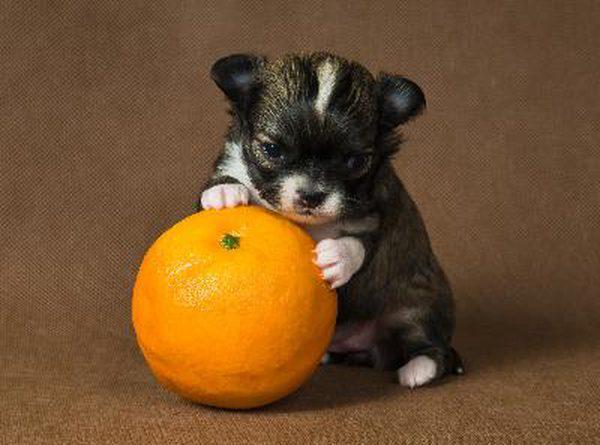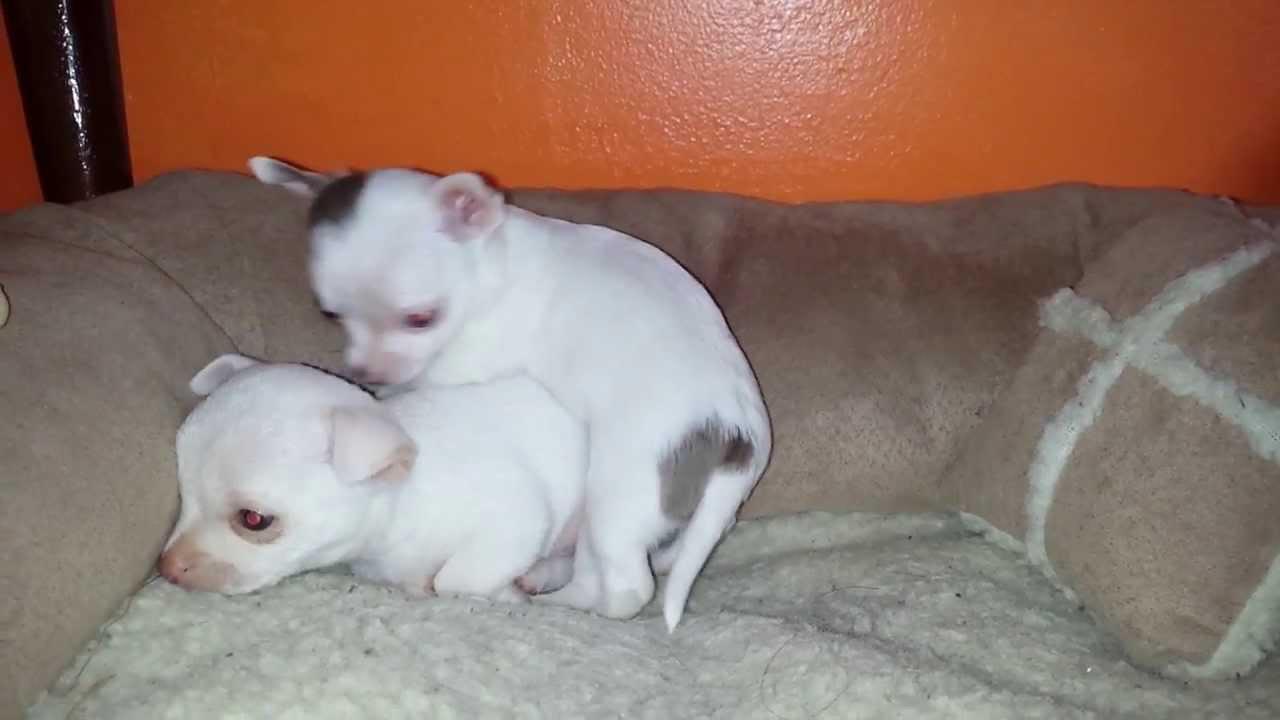The first image is the image on the left, the second image is the image on the right. Evaluate the accuracy of this statement regarding the images: "Someone is holding at least one of the animals in all of the images.". Is it true? Answer yes or no. No. The first image is the image on the left, the second image is the image on the right. Considering the images on both sides, is "At least one image shows a tiny puppy with closed eyes, held in the palm of a hand." valid? Answer yes or no. No. 